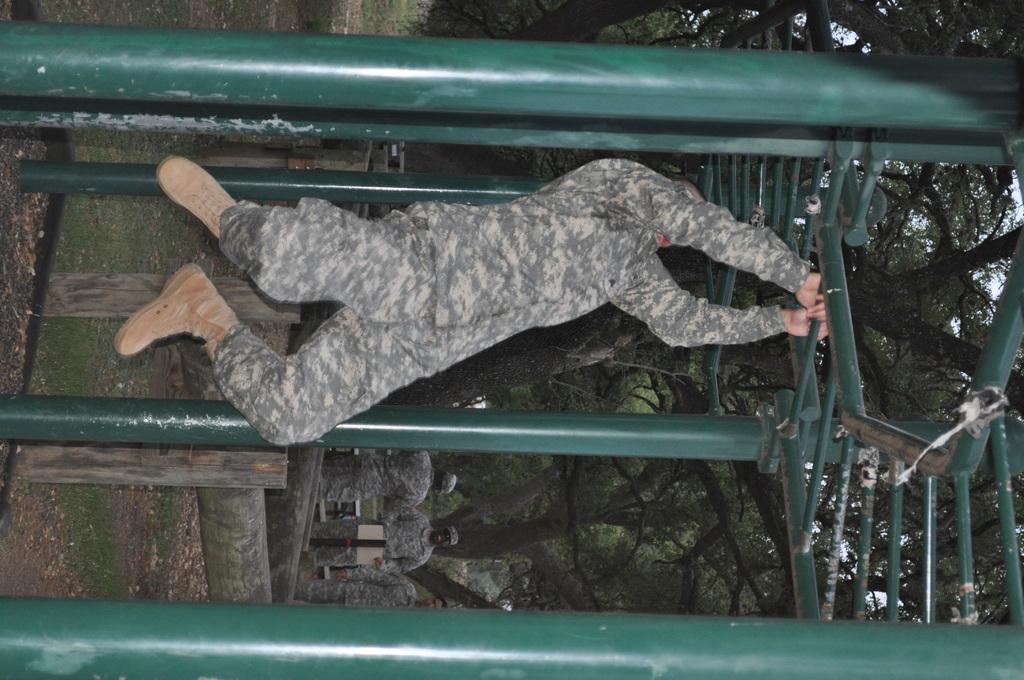Who is the main subject in the image? There is a man in the center of the image. What is the man holding in his hands? The man is holding a rod of a cage in his hands. What can be seen in the background of the image? There are trees and other men in the background of the image. What type of skin condition can be seen on the man's face in the image? There is no indication of a skin condition on the man's face in the image. 